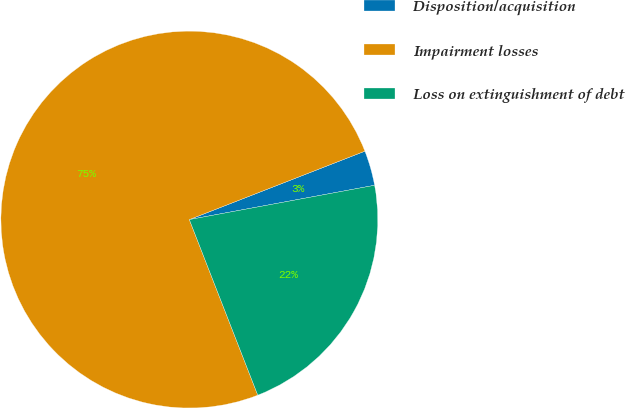Convert chart to OTSL. <chart><loc_0><loc_0><loc_500><loc_500><pie_chart><fcel>Disposition/acquisition<fcel>Impairment losses<fcel>Loss on extinguishment of debt<nl><fcel>3.0%<fcel>75.0%<fcel>22.0%<nl></chart> 